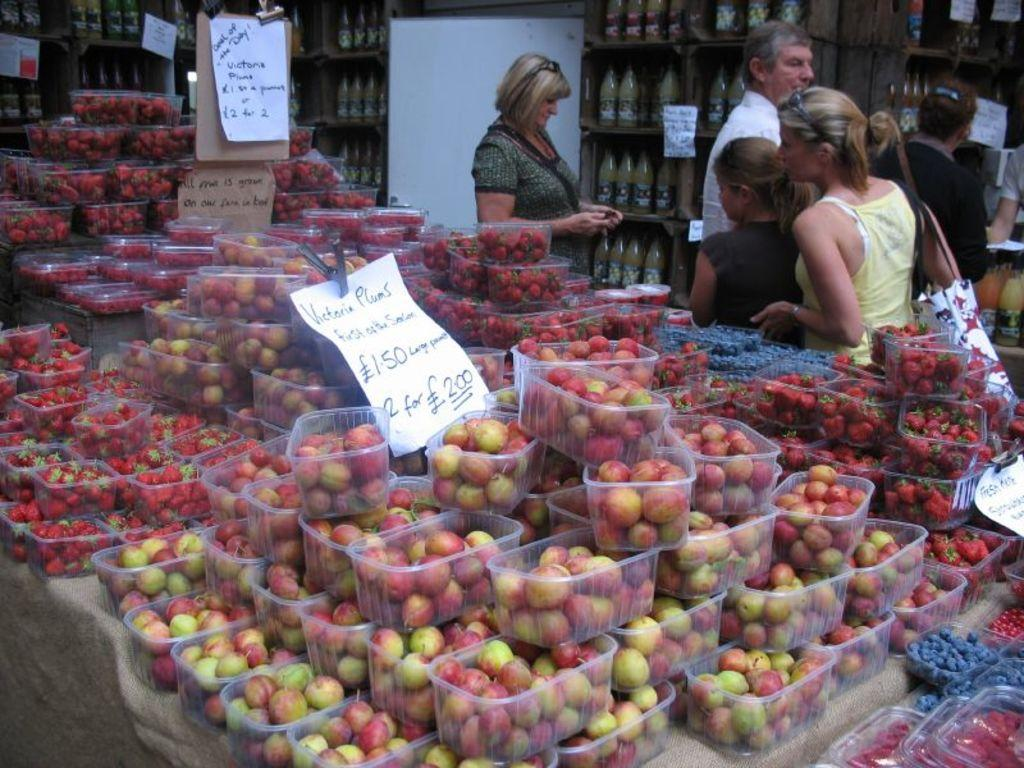What type of items are contained within the boxes in the image? There are fruits in the boxes in the image. What else can be seen in the image besides the boxes with fruits? There are papers with text and people in the image. Can you describe the lady's attire in the image? One lady is wearing a bag in the image. What can be seen in the background of the image? There are bottles in the racks in the background of the image. Where is the cemetery located in the image? There is no cemetery present in the image. What subject is the lady teaching in the image? There is no teaching activity depicted in the image. 